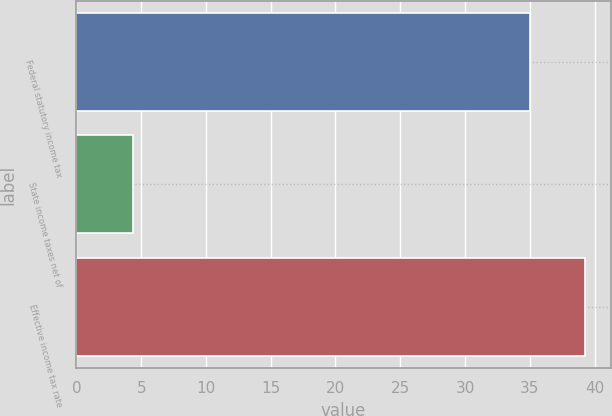Convert chart. <chart><loc_0><loc_0><loc_500><loc_500><bar_chart><fcel>Federal statutory income tax<fcel>State income taxes net of<fcel>Effective income tax rate<nl><fcel>35<fcel>4.4<fcel>39.3<nl></chart> 